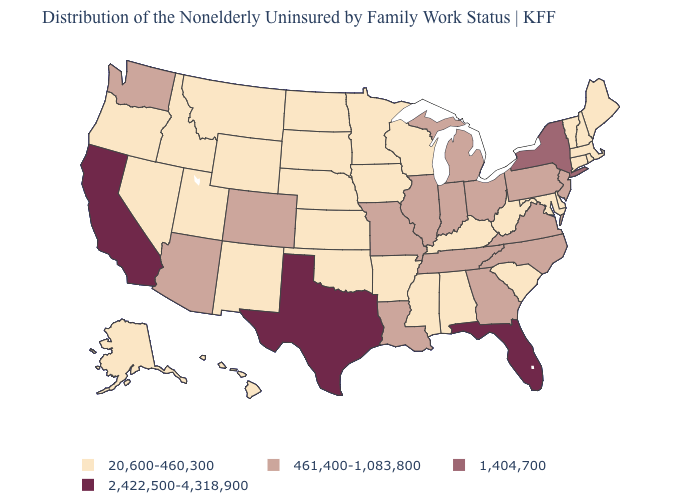How many symbols are there in the legend?
Quick response, please. 4. Which states have the lowest value in the South?
Write a very short answer. Alabama, Arkansas, Delaware, Kentucky, Maryland, Mississippi, Oklahoma, South Carolina, West Virginia. Name the states that have a value in the range 20,600-460,300?
Concise answer only. Alabama, Alaska, Arkansas, Connecticut, Delaware, Hawaii, Idaho, Iowa, Kansas, Kentucky, Maine, Maryland, Massachusetts, Minnesota, Mississippi, Montana, Nebraska, Nevada, New Hampshire, New Mexico, North Dakota, Oklahoma, Oregon, Rhode Island, South Carolina, South Dakota, Utah, Vermont, West Virginia, Wisconsin, Wyoming. Name the states that have a value in the range 20,600-460,300?
Be succinct. Alabama, Alaska, Arkansas, Connecticut, Delaware, Hawaii, Idaho, Iowa, Kansas, Kentucky, Maine, Maryland, Massachusetts, Minnesota, Mississippi, Montana, Nebraska, Nevada, New Hampshire, New Mexico, North Dakota, Oklahoma, Oregon, Rhode Island, South Carolina, South Dakota, Utah, Vermont, West Virginia, Wisconsin, Wyoming. Name the states that have a value in the range 1,404,700?
Write a very short answer. New York. How many symbols are there in the legend?
Concise answer only. 4. Which states have the highest value in the USA?
Short answer required. California, Florida, Texas. Does the map have missing data?
Answer briefly. No. Does Georgia have the highest value in the USA?
Write a very short answer. No. Name the states that have a value in the range 1,404,700?
Write a very short answer. New York. What is the lowest value in the South?
Short answer required. 20,600-460,300. Does the first symbol in the legend represent the smallest category?
Short answer required. Yes. What is the value of Nevada?
Be succinct. 20,600-460,300. How many symbols are there in the legend?
Short answer required. 4. What is the value of Wisconsin?
Give a very brief answer. 20,600-460,300. 